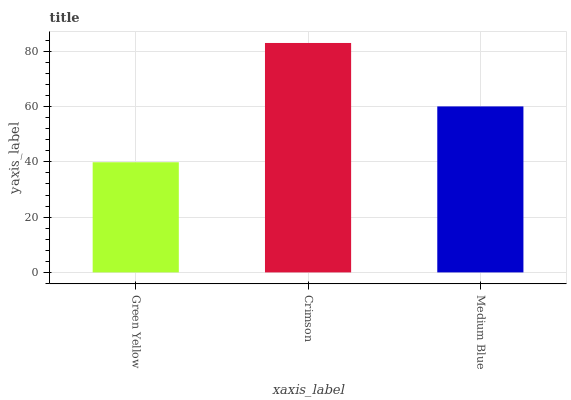Is Green Yellow the minimum?
Answer yes or no. Yes. Is Crimson the maximum?
Answer yes or no. Yes. Is Medium Blue the minimum?
Answer yes or no. No. Is Medium Blue the maximum?
Answer yes or no. No. Is Crimson greater than Medium Blue?
Answer yes or no. Yes. Is Medium Blue less than Crimson?
Answer yes or no. Yes. Is Medium Blue greater than Crimson?
Answer yes or no. No. Is Crimson less than Medium Blue?
Answer yes or no. No. Is Medium Blue the high median?
Answer yes or no. Yes. Is Medium Blue the low median?
Answer yes or no. Yes. Is Crimson the high median?
Answer yes or no. No. Is Green Yellow the low median?
Answer yes or no. No. 